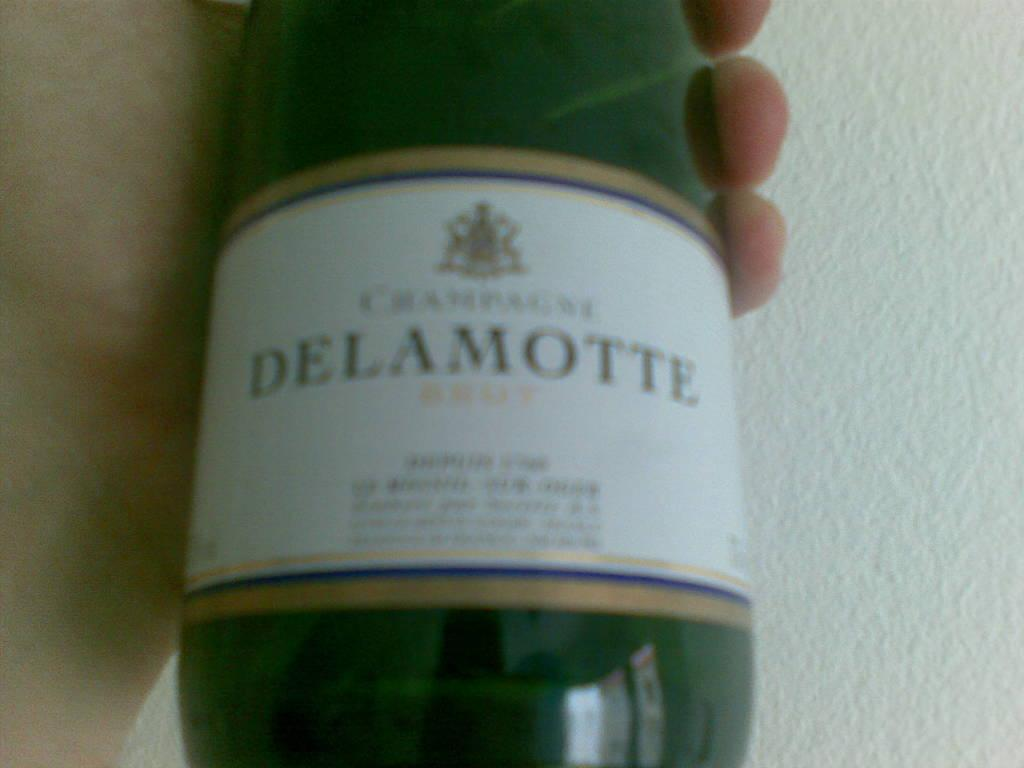<image>
Summarize the visual content of the image. a green glass bottle of Delamotte held in a hand 